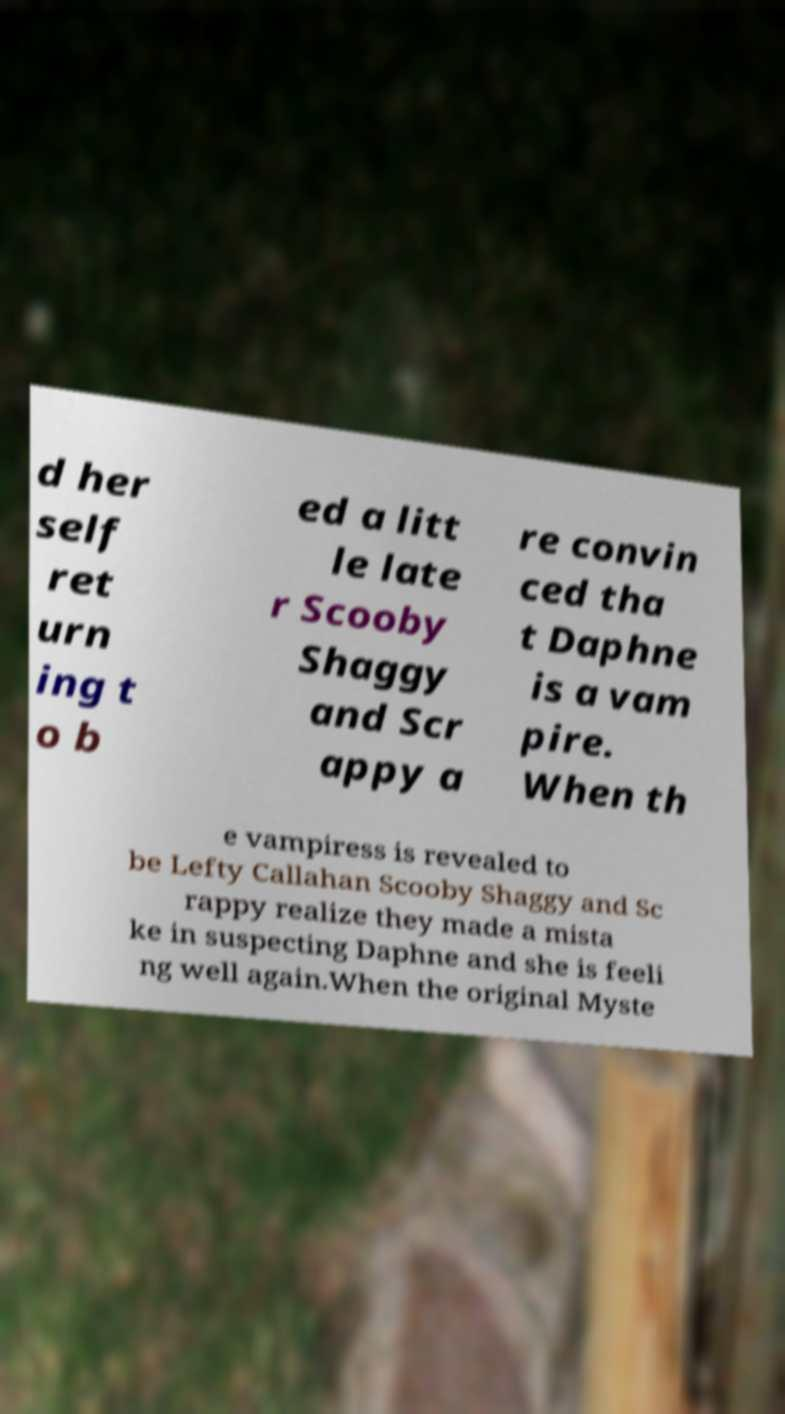Please read and relay the text visible in this image. What does it say? d her self ret urn ing t o b ed a litt le late r Scooby Shaggy and Scr appy a re convin ced tha t Daphne is a vam pire. When th e vampiress is revealed to be Lefty Callahan Scooby Shaggy and Sc rappy realize they made a mista ke in suspecting Daphne and she is feeli ng well again.When the original Myste 